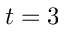<formula> <loc_0><loc_0><loc_500><loc_500>t = 3</formula> 